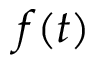Convert formula to latex. <formula><loc_0><loc_0><loc_500><loc_500>f ( t )</formula> 